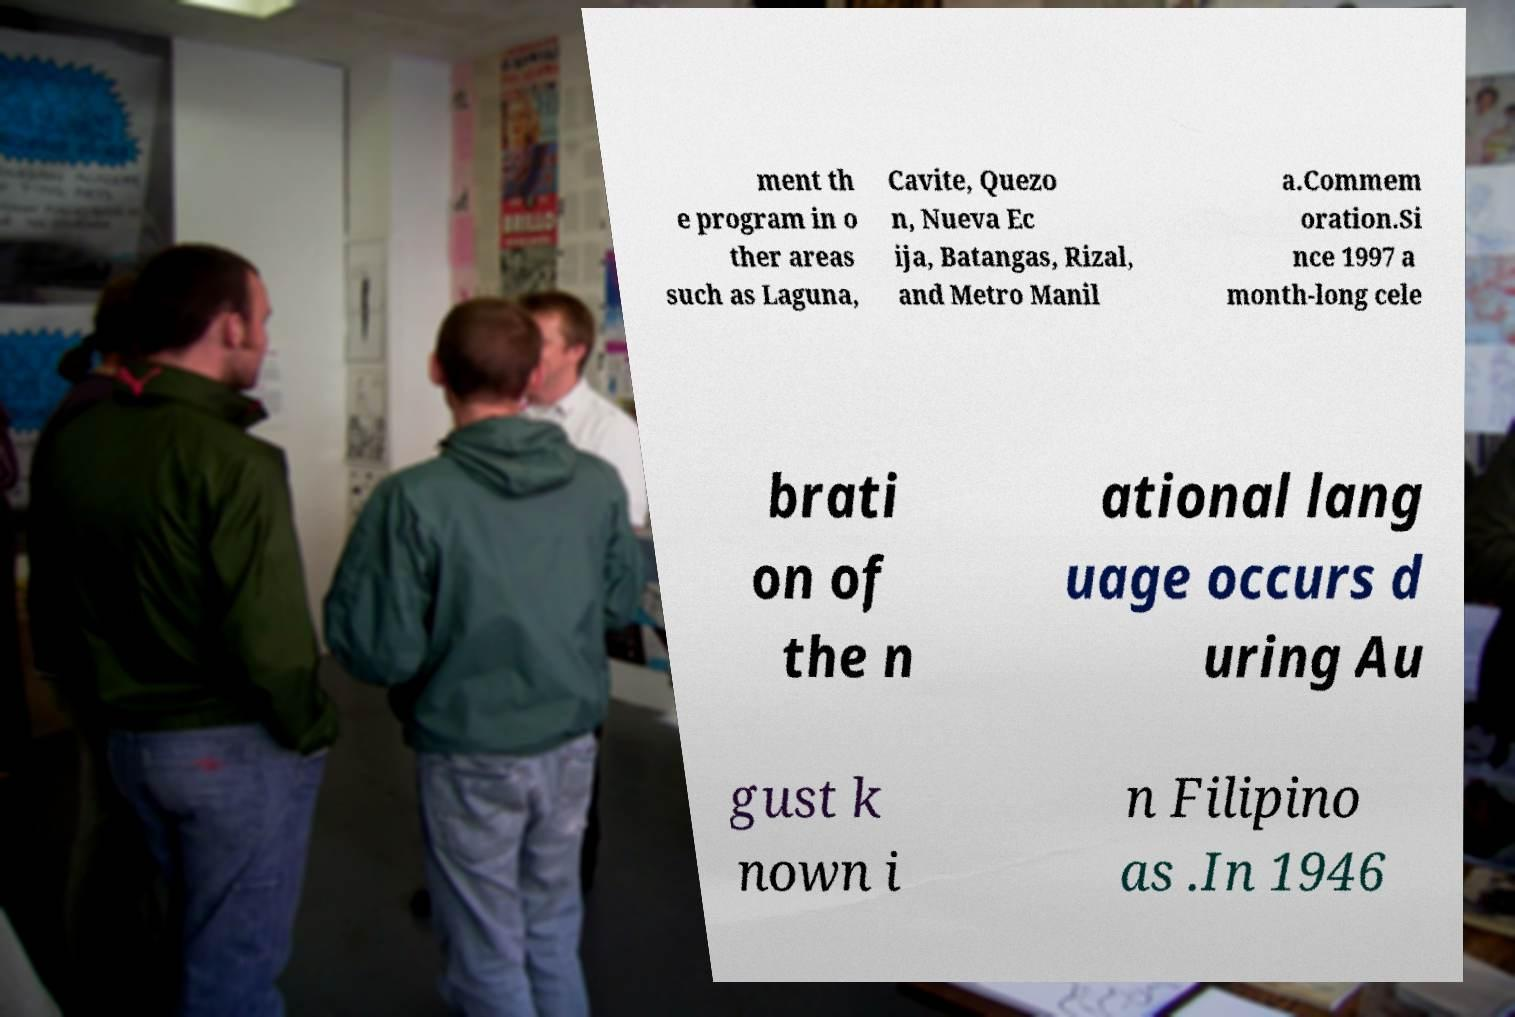What messages or text are displayed in this image? I need them in a readable, typed format. ment th e program in o ther areas such as Laguna, Cavite, Quezo n, Nueva Ec ija, Batangas, Rizal, and Metro Manil a.Commem oration.Si nce 1997 a month-long cele brati on of the n ational lang uage occurs d uring Au gust k nown i n Filipino as .In 1946 